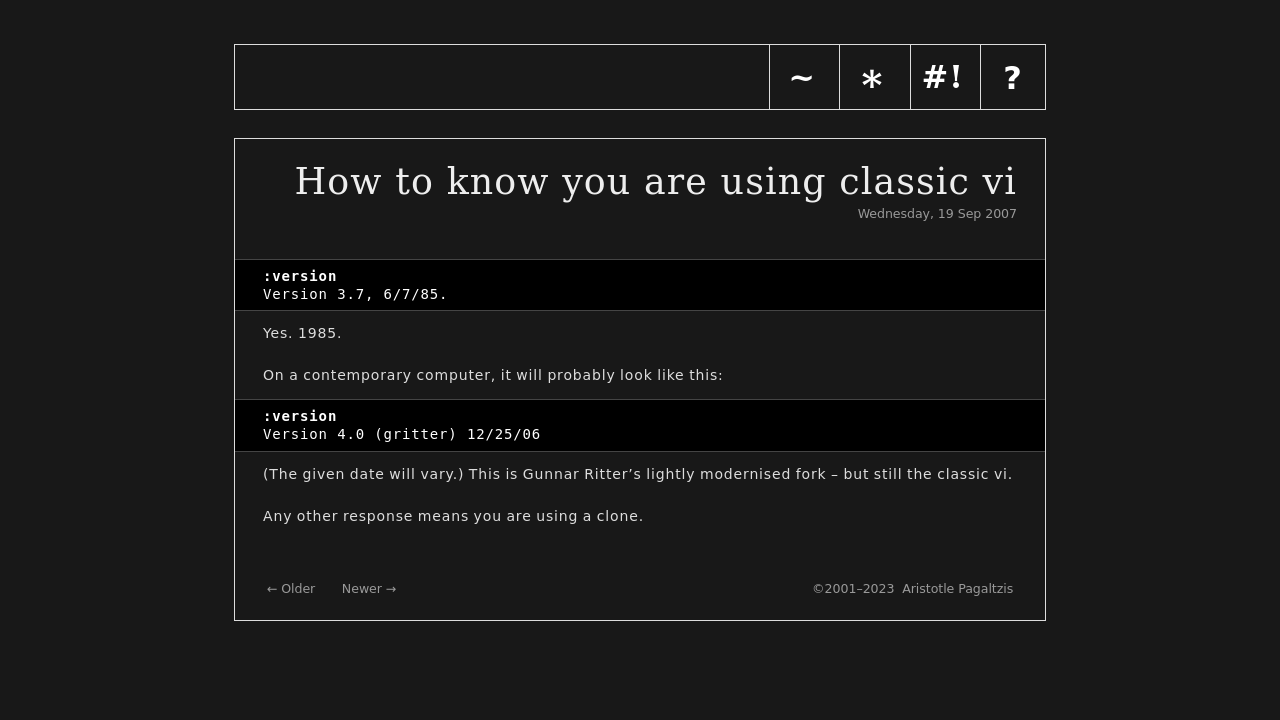What's the procedure for constructing this website from scratch with HTML? To build a website similar to the one shown in the image from scratch using HTML, you'll start by setting up a basic HTML structure. First, create a doctype declaration and define the html element with a lang attribute. You need a head section for meta tags, title, and CSS for styling. Your style tags will include CSS rules to recreate the black-and-grey theme, typography, and layout as seen. In the body, use divs and navigation elements structured in an organized manner. Lastly, include content sections with placeholder text, ensuring the design is responsive. Don't forget to frequently test your site in multiple browsers to ensure compatibility and responsiveness. 